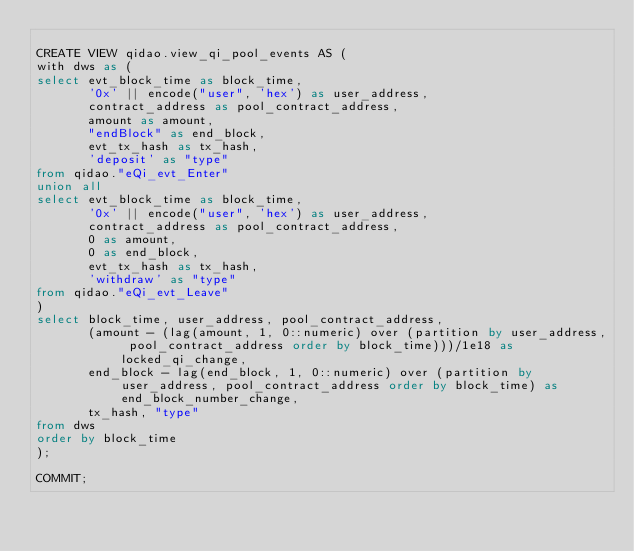Convert code to text. <code><loc_0><loc_0><loc_500><loc_500><_SQL_>
CREATE VIEW qidao.view_qi_pool_events AS (
with dws as (
select evt_block_time as block_time,
       '0x' || encode("user", 'hex') as user_address,
       contract_address as pool_contract_address,
       amount as amount,
       "endBlock" as end_block,
       evt_tx_hash as tx_hash,
       'deposit' as "type"
from qidao."eQi_evt_Enter"
union all
select evt_block_time as block_time,
       '0x' || encode("user", 'hex') as user_address,
       contract_address as pool_contract_address,
       0 as amount,
       0 as end_block,
       evt_tx_hash as tx_hash,
       'withdraw' as "type"
from qidao."eQi_evt_Leave"
)
select block_time, user_address, pool_contract_address,
       (amount - (lag(amount, 1, 0::numeric) over (partition by user_address, pool_contract_address order by block_time)))/1e18 as locked_qi_change,
       end_block - lag(end_block, 1, 0::numeric) over (partition by user_address, pool_contract_address order by block_time) as end_block_number_change,
       tx_hash, "type"
from dws
order by block_time
);

COMMIT;</code> 